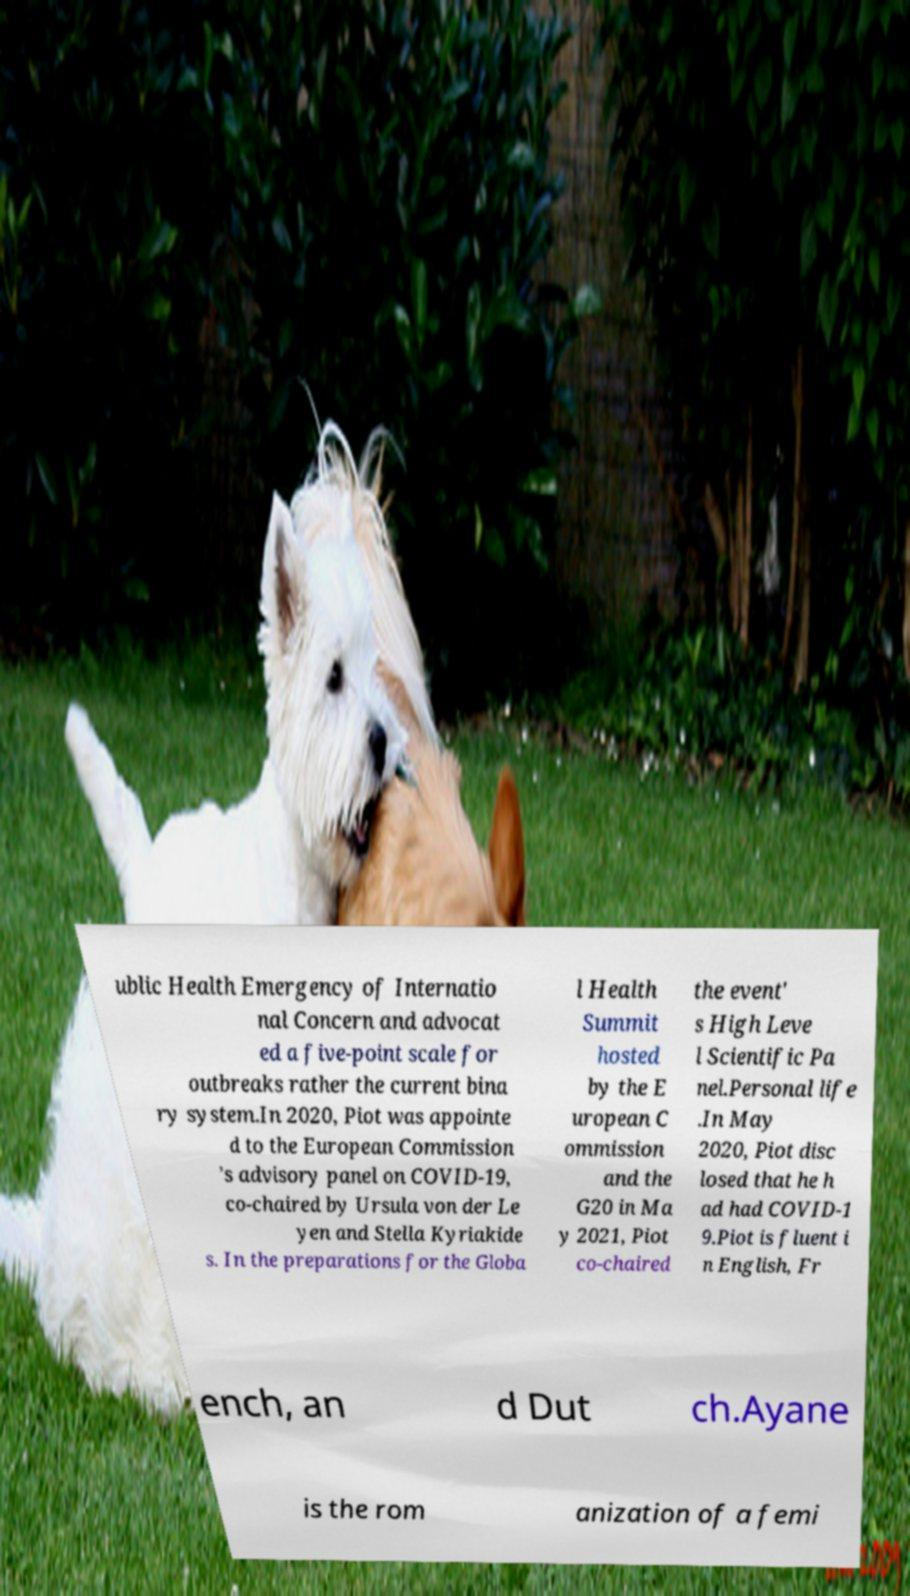Please read and relay the text visible in this image. What does it say? ublic Health Emergency of Internatio nal Concern and advocat ed a five-point scale for outbreaks rather the current bina ry system.In 2020, Piot was appointe d to the European Commission ’s advisory panel on COVID-19, co-chaired by Ursula von der Le yen and Stella Kyriakide s. In the preparations for the Globa l Health Summit hosted by the E uropean C ommission and the G20 in Ma y 2021, Piot co-chaired the event' s High Leve l Scientific Pa nel.Personal life .In May 2020, Piot disc losed that he h ad had COVID-1 9.Piot is fluent i n English, Fr ench, an d Dut ch.Ayane is the rom anization of a femi 